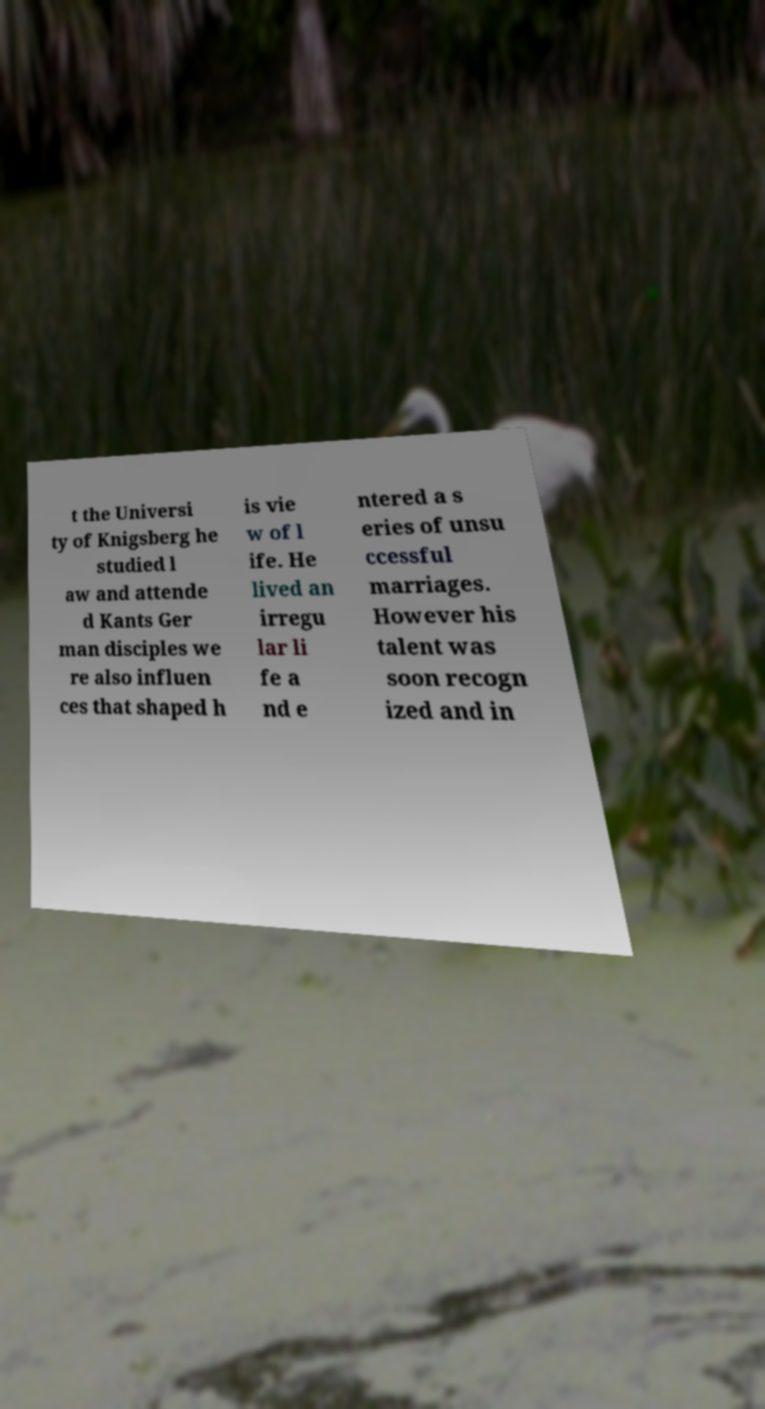I need the written content from this picture converted into text. Can you do that? t the Universi ty of Knigsberg he studied l aw and attende d Kants Ger man disciples we re also influen ces that shaped h is vie w of l ife. He lived an irregu lar li fe a nd e ntered a s eries of unsu ccessful marriages. However his talent was soon recogn ized and in 